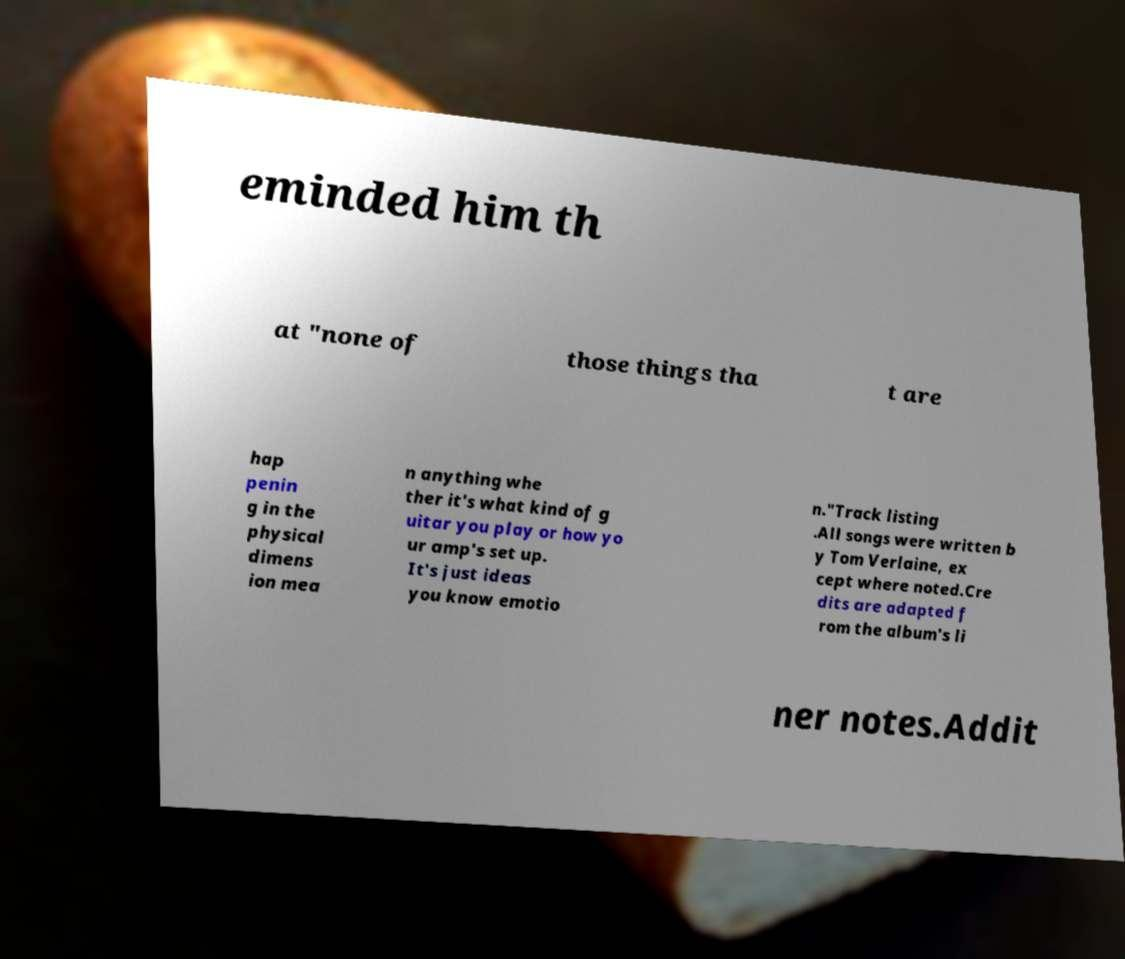For documentation purposes, I need the text within this image transcribed. Could you provide that? eminded him th at "none of those things tha t are hap penin g in the physical dimens ion mea n anything whe ther it's what kind of g uitar you play or how yo ur amp's set up. It's just ideas you know emotio n."Track listing .All songs were written b y Tom Verlaine, ex cept where noted.Cre dits are adapted f rom the album's li ner notes.Addit 